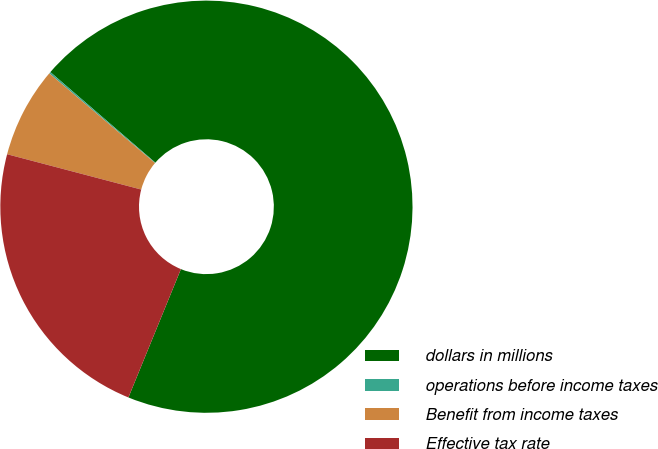<chart> <loc_0><loc_0><loc_500><loc_500><pie_chart><fcel>dollars in millions<fcel>operations before income taxes<fcel>Benefit from income taxes<fcel>Effective tax rate<nl><fcel>69.85%<fcel>0.13%<fcel>7.1%<fcel>22.92%<nl></chart> 